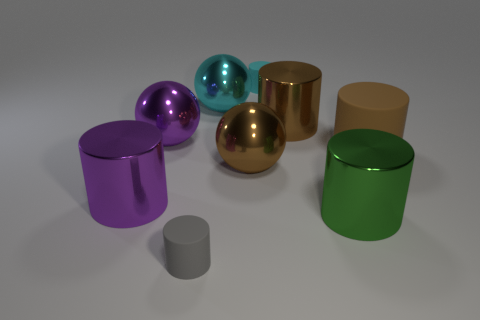Subtract all cyan cylinders. How many cylinders are left? 5 Subtract all big purple cylinders. How many cylinders are left? 5 Subtract all green cylinders. Subtract all cyan cubes. How many cylinders are left? 5 Subtract all cylinders. How many objects are left? 3 Add 7 small gray rubber cylinders. How many small gray rubber cylinders exist? 8 Subtract 0 purple blocks. How many objects are left? 9 Subtract all big cyan balls. Subtract all cyan metallic balls. How many objects are left? 7 Add 4 cylinders. How many cylinders are left? 10 